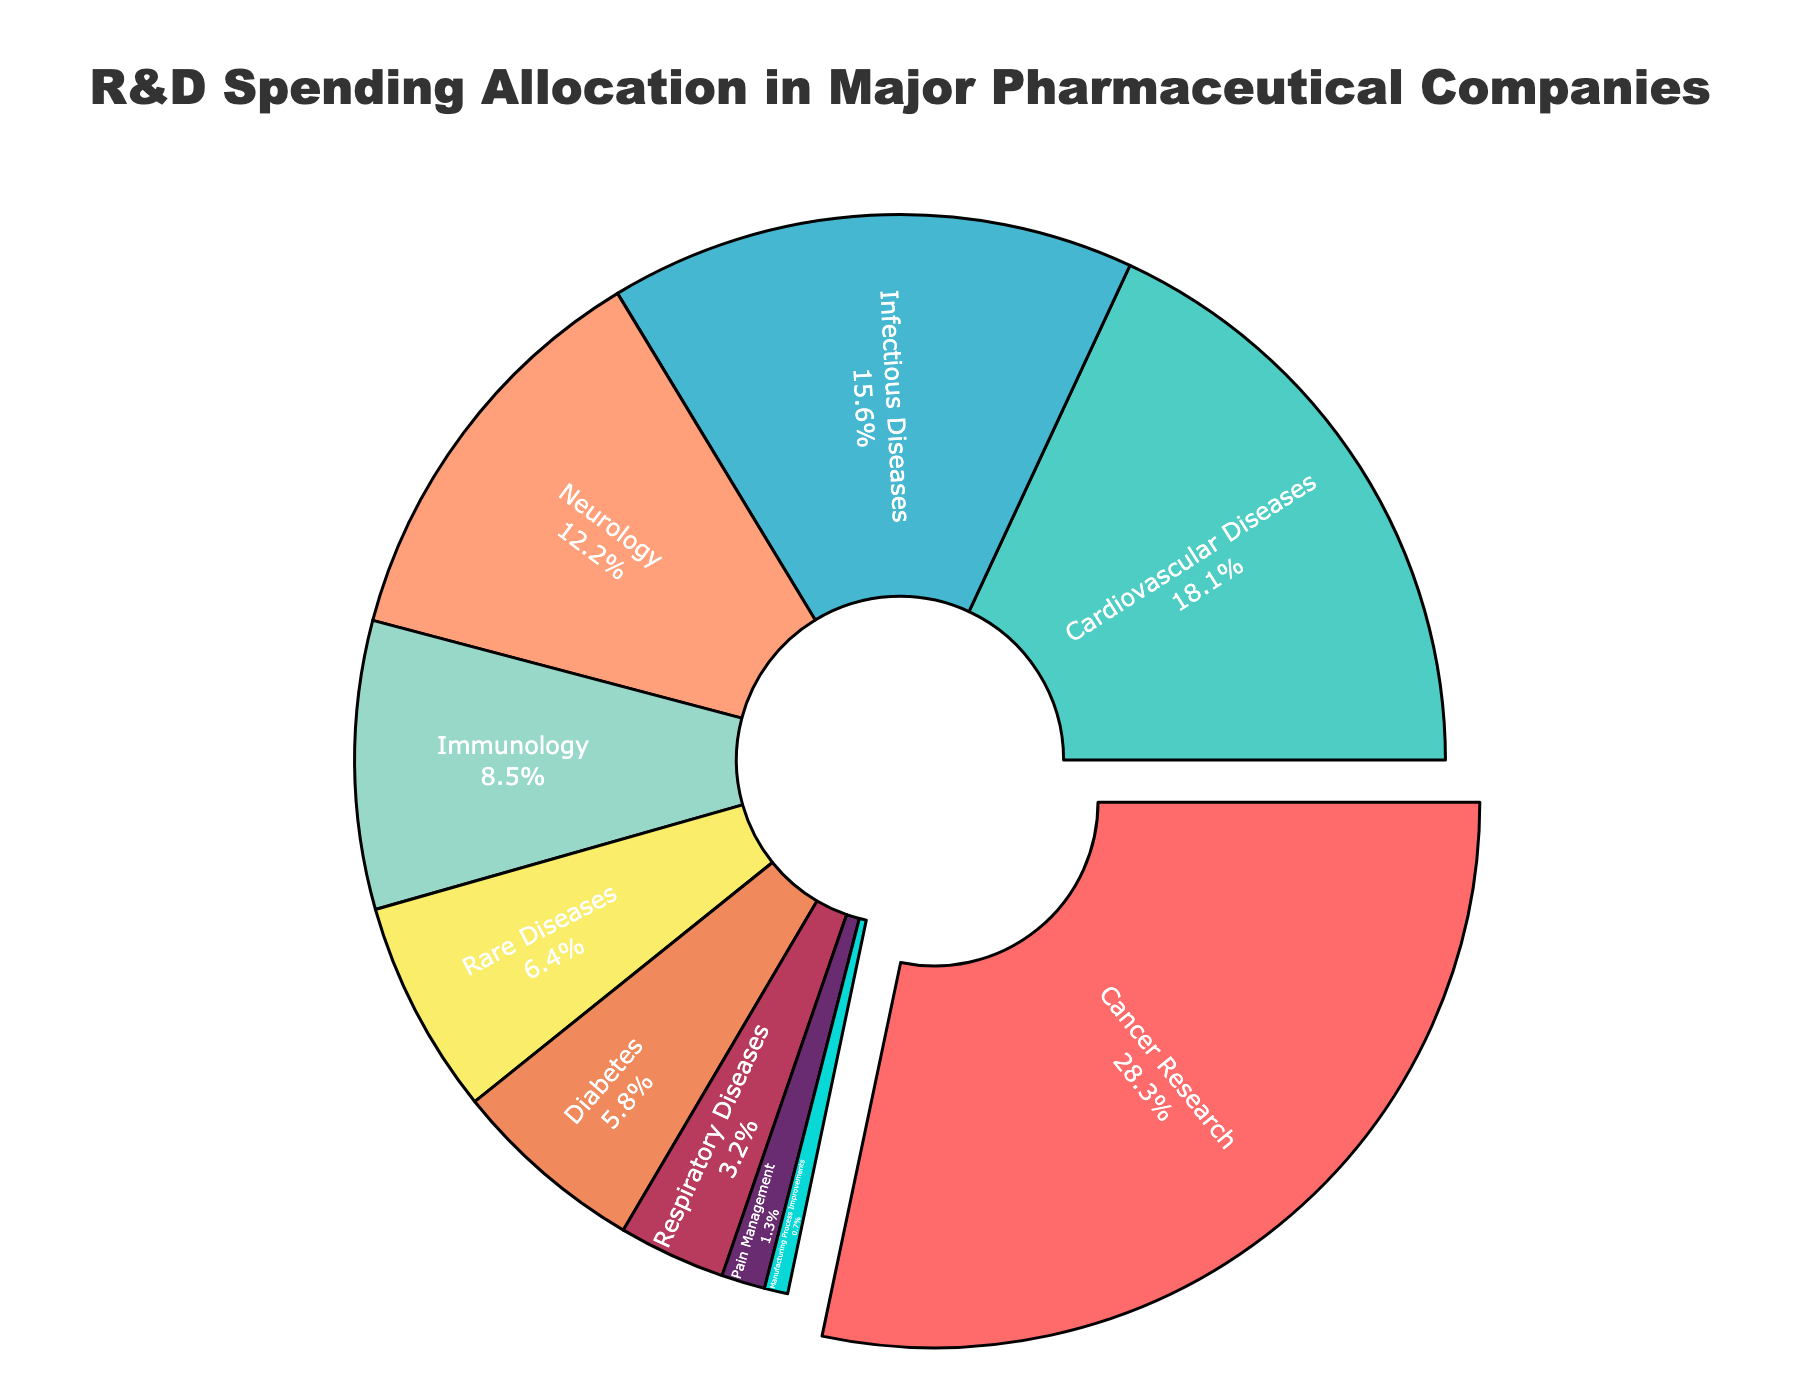Which category has the largest percentage allocation? To determine the category with the largest allocation, look at the segment with the highest percentage. The figure marks "Cancer Research" at 28.5%, which is the largest.
Answer: Cancer Research How much more is spent on Cancer Research compared to Pain Management? To find the difference, subtract the Pain Management percentage (1.3%) from the Cancer Research percentage (28.5%). The difference is 28.5% - 1.3% = 27.2%.
Answer: 27.2% What is the total percentage of spending on Neurology and Immunology combined? To find the total, add the percentages for Neurology (12.3%) and Immunology (8.6%). 12.3% + 8.6% = 20.9%.
Answer: 20.9% Which categories have a higher allocation than Diabetes? Identify the categories with a percentage greater than 5.8% (Diabetes). These are Cancer Research (28.5%), Cardiovascular Diseases (18.2%), Infectious Diseases (15.7%), Neurology (12.3%), and Immunology (8.6%).
Answer: Cancer Research, Cardiovascular Diseases, Infectious Diseases, Neurology, Immunology Which category is represented by the smallest segment in the pie chart? The smallest segment corresponds to the category with the smallest allocation, which is "Manufacturing Process Improvements" at 0.7%.
Answer: Manufacturing Process Improvements How does the percentage spent on Rare Diseases compare to that of Respiratory Diseases? Compare the percentages directly: Rare Diseases (6.4%) and Respiratory Diseases (3.2%). 6.4% > 3.2%, so Rare Diseases have a higher allocation.
Answer: Rare Diseases have a higher allocation What is the combined percentage allocation for categories with less than 10% spending each? Sum the percentages for categories with allocations under 10%: Immunology (8.6%) + Rare Diseases (6.4%) + Diabetes (5.8%) + Respiratory Diseases (3.2%) + Pain Management (1.3%) + Manufacturing Process Improvements (0.7%). 8.6% + 6.4% + 5.8% + 3.2% + 1.3% + 0.7% = 26.0%.
Answer: 26.0% If you remove the Cancer Research segment, which category has the largest remaining percentage? Exclude Cancer Research at 28.5%, then identify the next largest segment, which is Cardiovascular Diseases at 18.2%.
Answer: Cardiovascular Diseases 